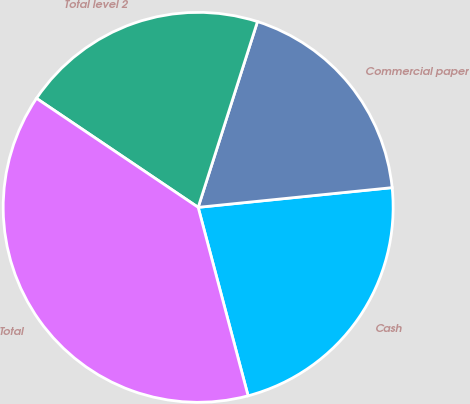Convert chart. <chart><loc_0><loc_0><loc_500><loc_500><pie_chart><fcel>Cash<fcel>Commercial paper<fcel>Total level 2<fcel>Total<nl><fcel>22.49%<fcel>18.47%<fcel>20.48%<fcel>38.56%<nl></chart> 